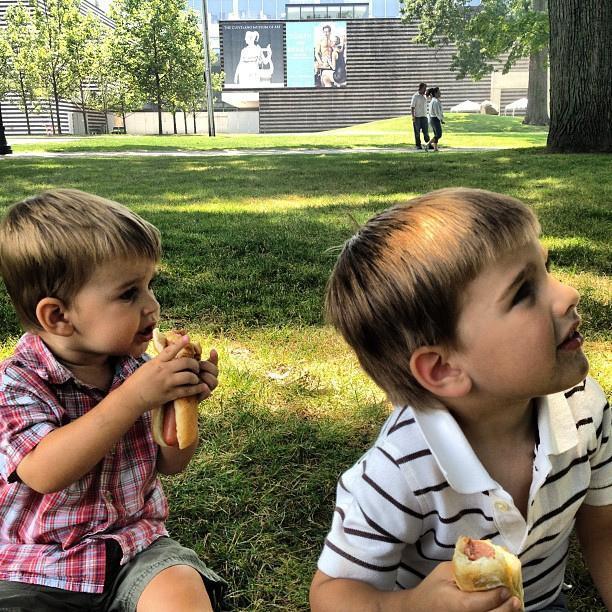How many people are visible?
Give a very brief answer. 2. How many hot dogs are there?
Give a very brief answer. 2. How many skateboard wheels can you see?
Give a very brief answer. 0. 